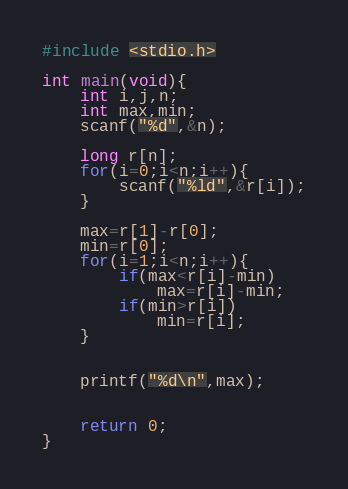Convert code to text. <code><loc_0><loc_0><loc_500><loc_500><_C_>#include <stdio.h>

int main(void){
	int i,j,n;
	int max,min;
	scanf("%d",&n);
	
	long r[n];
	for(i=0;i<n;i++){
		scanf("%ld",&r[i]);
	}
	
	max=r[1]-r[0];
	min=r[0];
	for(i=1;i<n;i++){
		if(max<r[i]-min)
			max=r[i]-min;
		if(min>r[i])
			min=r[i];
	}
	
	
	printf("%d\n",max);
	
	
	return 0;
}</code> 